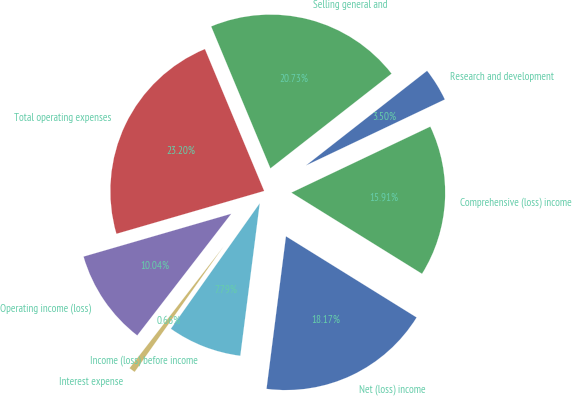Convert chart to OTSL. <chart><loc_0><loc_0><loc_500><loc_500><pie_chart><fcel>Research and development<fcel>Selling general and<fcel>Total operating expenses<fcel>Operating income (loss)<fcel>Interest expense<fcel>Income (loss) before income<fcel>Net (loss) income<fcel>Comprehensive (loss) income<nl><fcel>3.5%<fcel>20.73%<fcel>23.2%<fcel>10.04%<fcel>0.66%<fcel>7.79%<fcel>18.17%<fcel>15.91%<nl></chart> 